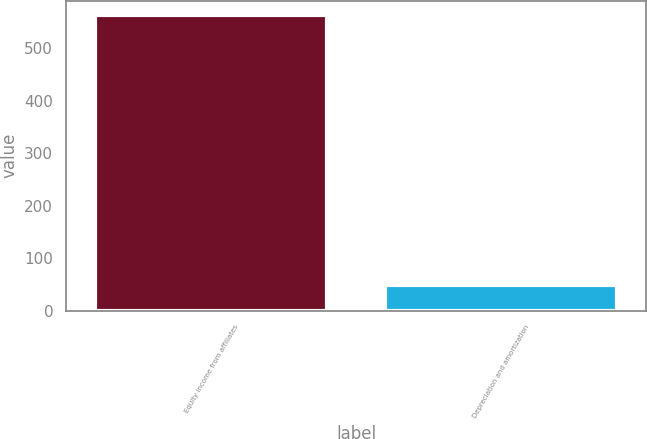<chart> <loc_0><loc_0><loc_500><loc_500><bar_chart><fcel>Equity income from affiliates<fcel>Depreciation and amortization<nl><fcel>563<fcel>49<nl></chart> 